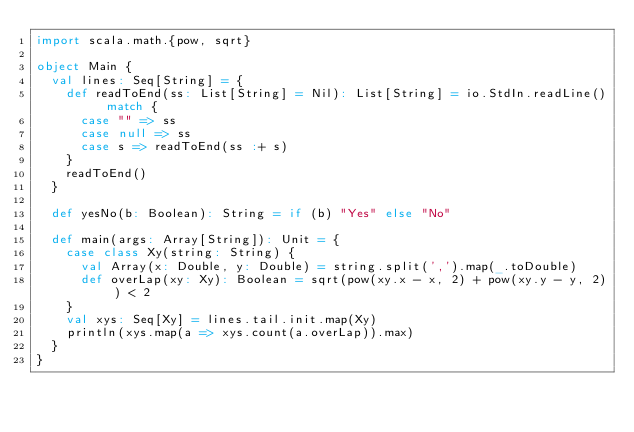<code> <loc_0><loc_0><loc_500><loc_500><_Scala_>import scala.math.{pow, sqrt}

object Main {
  val lines: Seq[String] = {
    def readToEnd(ss: List[String] = Nil): List[String] = io.StdIn.readLine() match {
      case "" => ss
      case null => ss
      case s => readToEnd(ss :+ s)
    }
    readToEnd()
  }

  def yesNo(b: Boolean): String = if (b) "Yes" else "No"

  def main(args: Array[String]): Unit = {
    case class Xy(string: String) {
      val Array(x: Double, y: Double) = string.split(',').map(_.toDouble)
      def overLap(xy: Xy): Boolean = sqrt(pow(xy.x - x, 2) + pow(xy.y - y, 2)) < 2
    }
    val xys: Seq[Xy] = lines.tail.init.map(Xy)
    println(xys.map(a => xys.count(a.overLap)).max)
  }
}</code> 